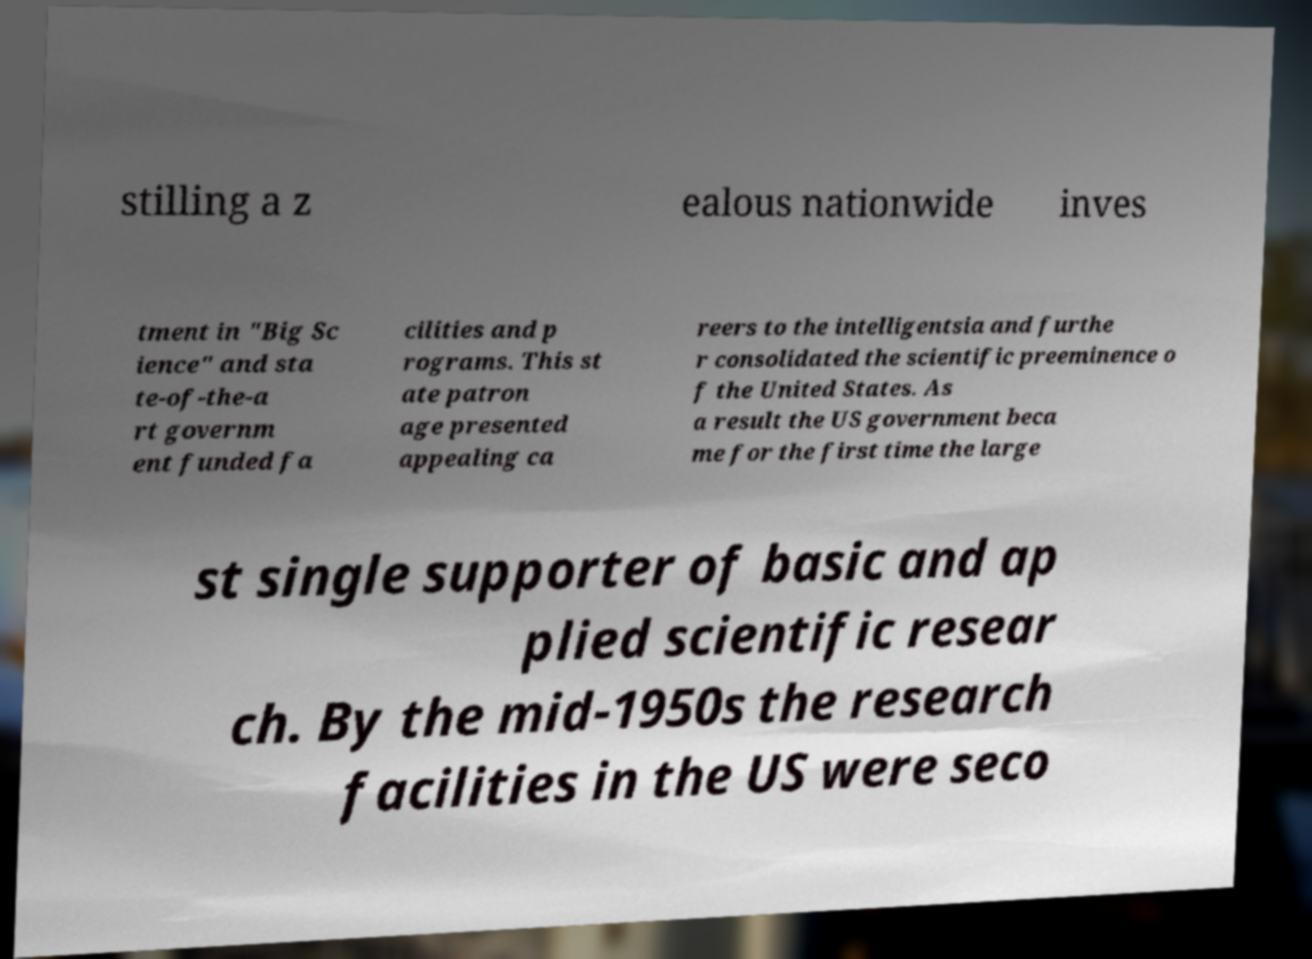For documentation purposes, I need the text within this image transcribed. Could you provide that? stilling a z ealous nationwide inves tment in "Big Sc ience" and sta te-of-the-a rt governm ent funded fa cilities and p rograms. This st ate patron age presented appealing ca reers to the intelligentsia and furthe r consolidated the scientific preeminence o f the United States. As a result the US government beca me for the first time the large st single supporter of basic and ap plied scientific resear ch. By the mid-1950s the research facilities in the US were seco 